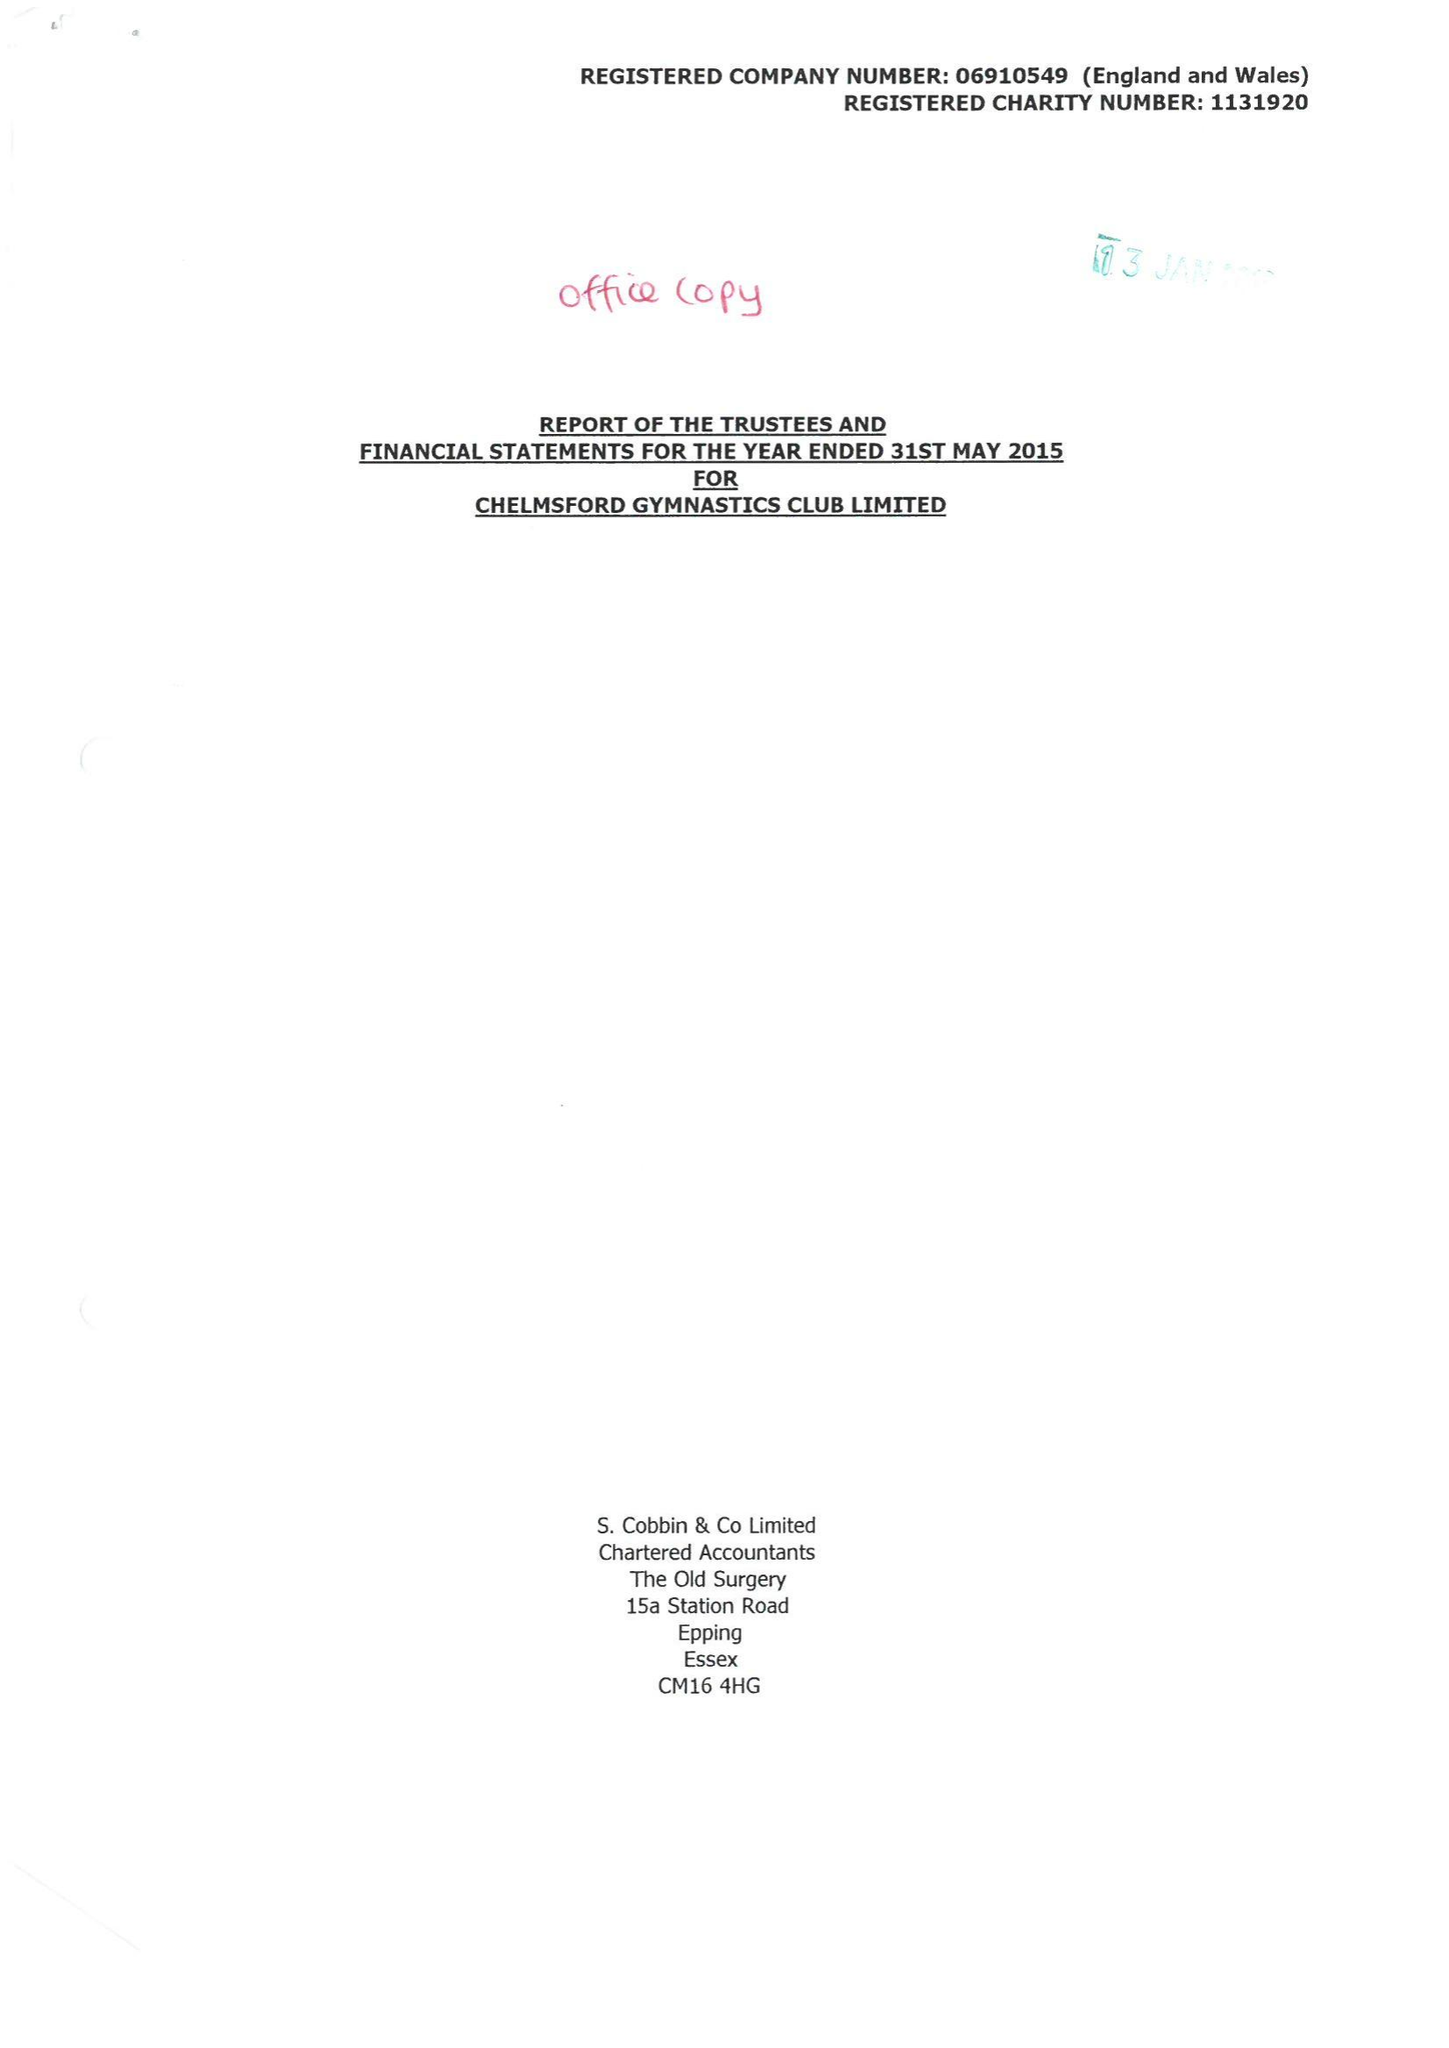What is the value for the charity_number?
Answer the question using a single word or phrase. 1131920 